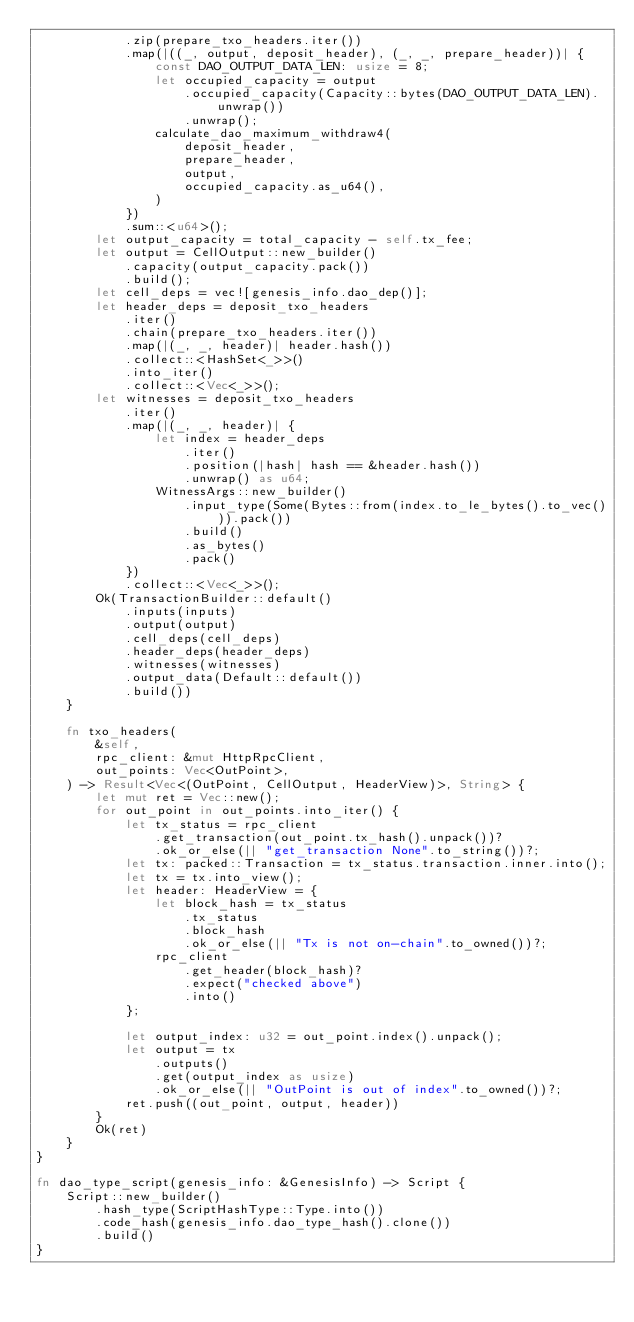Convert code to text. <code><loc_0><loc_0><loc_500><loc_500><_Rust_>            .zip(prepare_txo_headers.iter())
            .map(|((_, output, deposit_header), (_, _, prepare_header))| {
                const DAO_OUTPUT_DATA_LEN: usize = 8;
                let occupied_capacity = output
                    .occupied_capacity(Capacity::bytes(DAO_OUTPUT_DATA_LEN).unwrap())
                    .unwrap();
                calculate_dao_maximum_withdraw4(
                    deposit_header,
                    prepare_header,
                    output,
                    occupied_capacity.as_u64(),
                )
            })
            .sum::<u64>();
        let output_capacity = total_capacity - self.tx_fee;
        let output = CellOutput::new_builder()
            .capacity(output_capacity.pack())
            .build();
        let cell_deps = vec![genesis_info.dao_dep()];
        let header_deps = deposit_txo_headers
            .iter()
            .chain(prepare_txo_headers.iter())
            .map(|(_, _, header)| header.hash())
            .collect::<HashSet<_>>()
            .into_iter()
            .collect::<Vec<_>>();
        let witnesses = deposit_txo_headers
            .iter()
            .map(|(_, _, header)| {
                let index = header_deps
                    .iter()
                    .position(|hash| hash == &header.hash())
                    .unwrap() as u64;
                WitnessArgs::new_builder()
                    .input_type(Some(Bytes::from(index.to_le_bytes().to_vec())).pack())
                    .build()
                    .as_bytes()
                    .pack()
            })
            .collect::<Vec<_>>();
        Ok(TransactionBuilder::default()
            .inputs(inputs)
            .output(output)
            .cell_deps(cell_deps)
            .header_deps(header_deps)
            .witnesses(witnesses)
            .output_data(Default::default())
            .build())
    }

    fn txo_headers(
        &self,
        rpc_client: &mut HttpRpcClient,
        out_points: Vec<OutPoint>,
    ) -> Result<Vec<(OutPoint, CellOutput, HeaderView)>, String> {
        let mut ret = Vec::new();
        for out_point in out_points.into_iter() {
            let tx_status = rpc_client
                .get_transaction(out_point.tx_hash().unpack())?
                .ok_or_else(|| "get_transaction None".to_string())?;
            let tx: packed::Transaction = tx_status.transaction.inner.into();
            let tx = tx.into_view();
            let header: HeaderView = {
                let block_hash = tx_status
                    .tx_status
                    .block_hash
                    .ok_or_else(|| "Tx is not on-chain".to_owned())?;
                rpc_client
                    .get_header(block_hash)?
                    .expect("checked above")
                    .into()
            };

            let output_index: u32 = out_point.index().unpack();
            let output = tx
                .outputs()
                .get(output_index as usize)
                .ok_or_else(|| "OutPoint is out of index".to_owned())?;
            ret.push((out_point, output, header))
        }
        Ok(ret)
    }
}

fn dao_type_script(genesis_info: &GenesisInfo) -> Script {
    Script::new_builder()
        .hash_type(ScriptHashType::Type.into())
        .code_hash(genesis_info.dao_type_hash().clone())
        .build()
}
</code> 